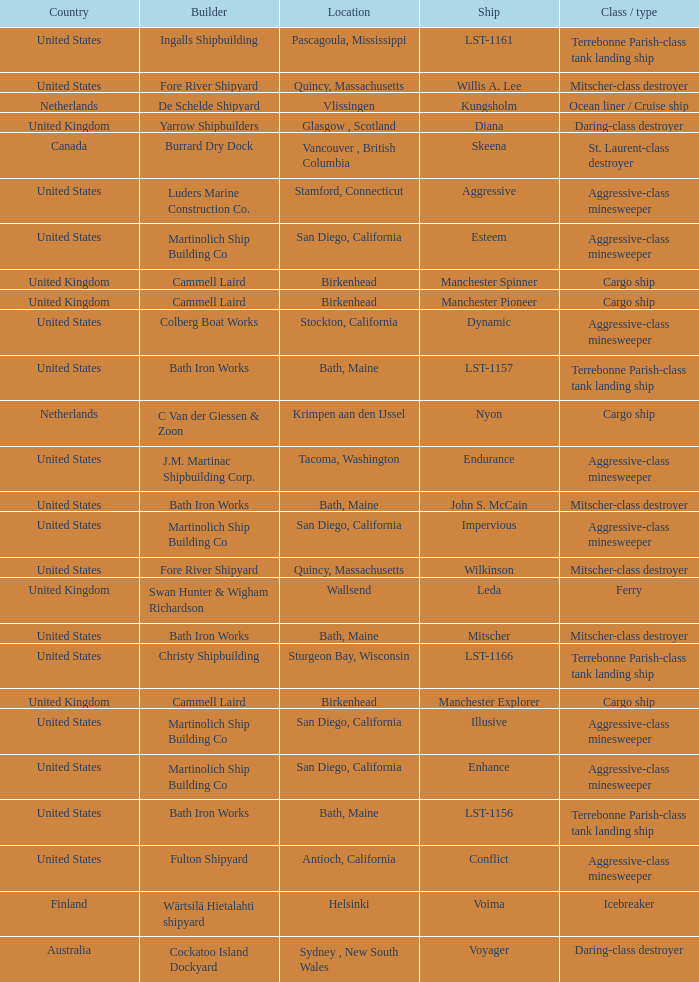What Ship was Built by Cammell Laird? Manchester Pioneer, Manchester Spinner, Manchester Explorer. 